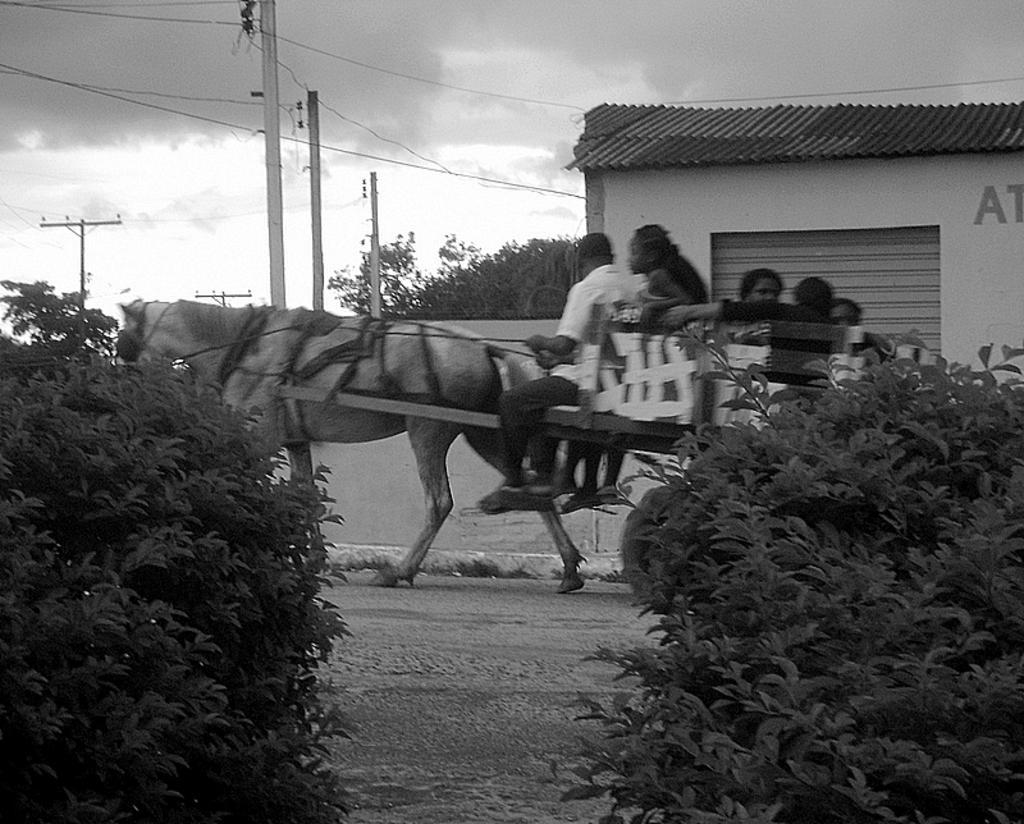Can you describe this image briefly? In this picture we can see some people sitting on the horse and riding it and around them there are two plants, poles and a shop. 